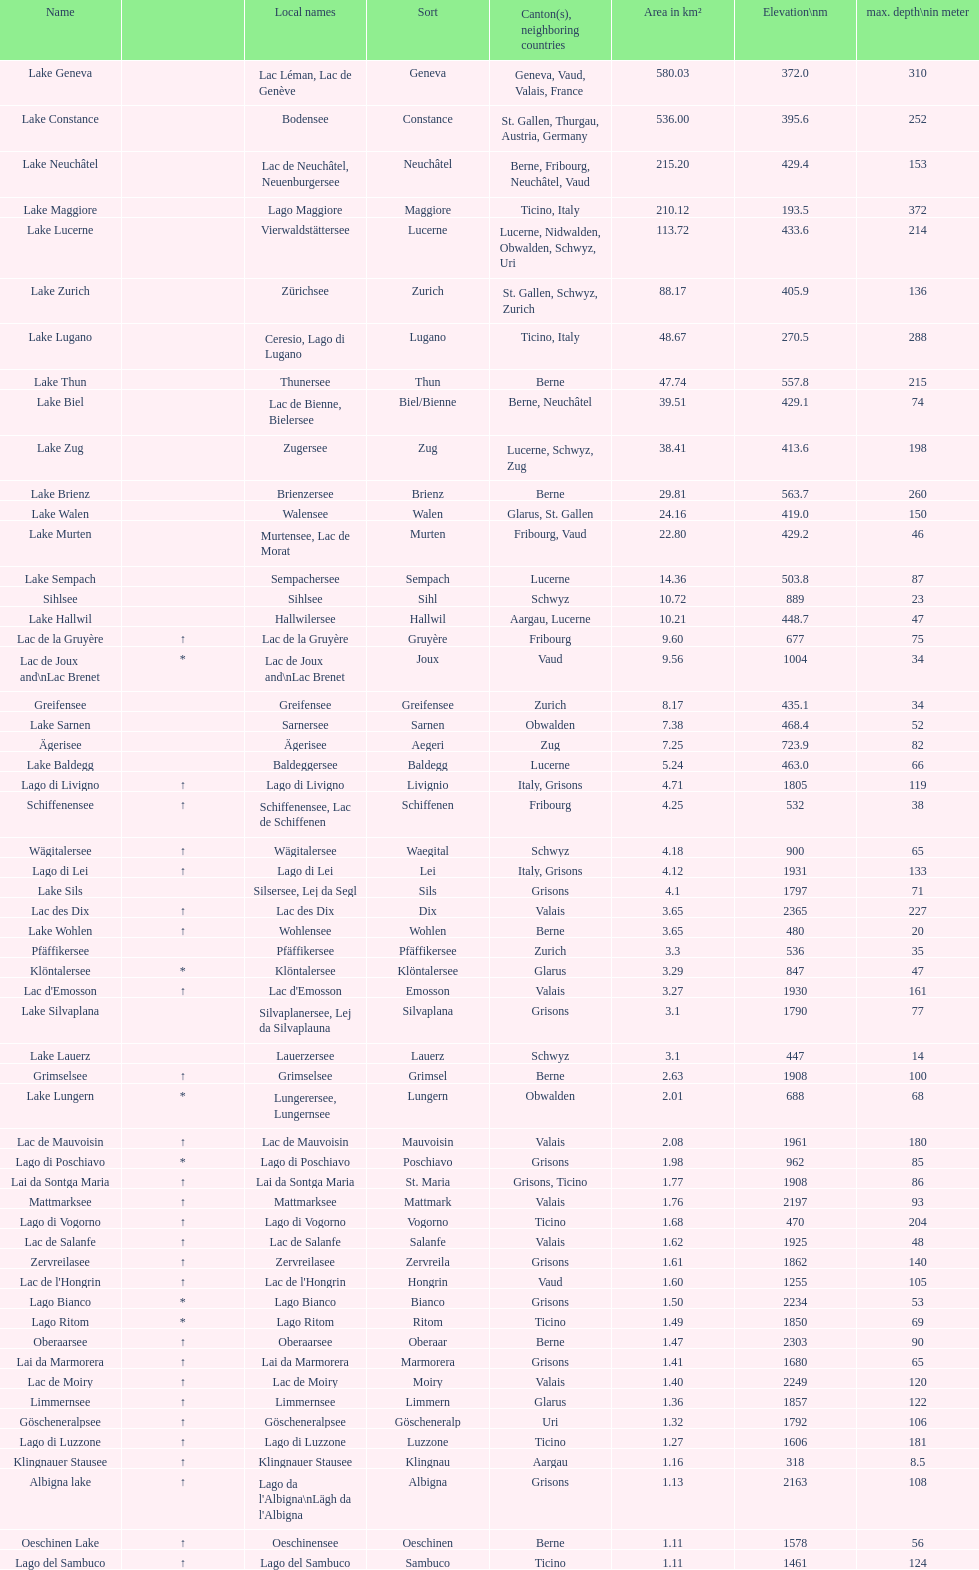What is the deepest lake? Lake Maggiore. 